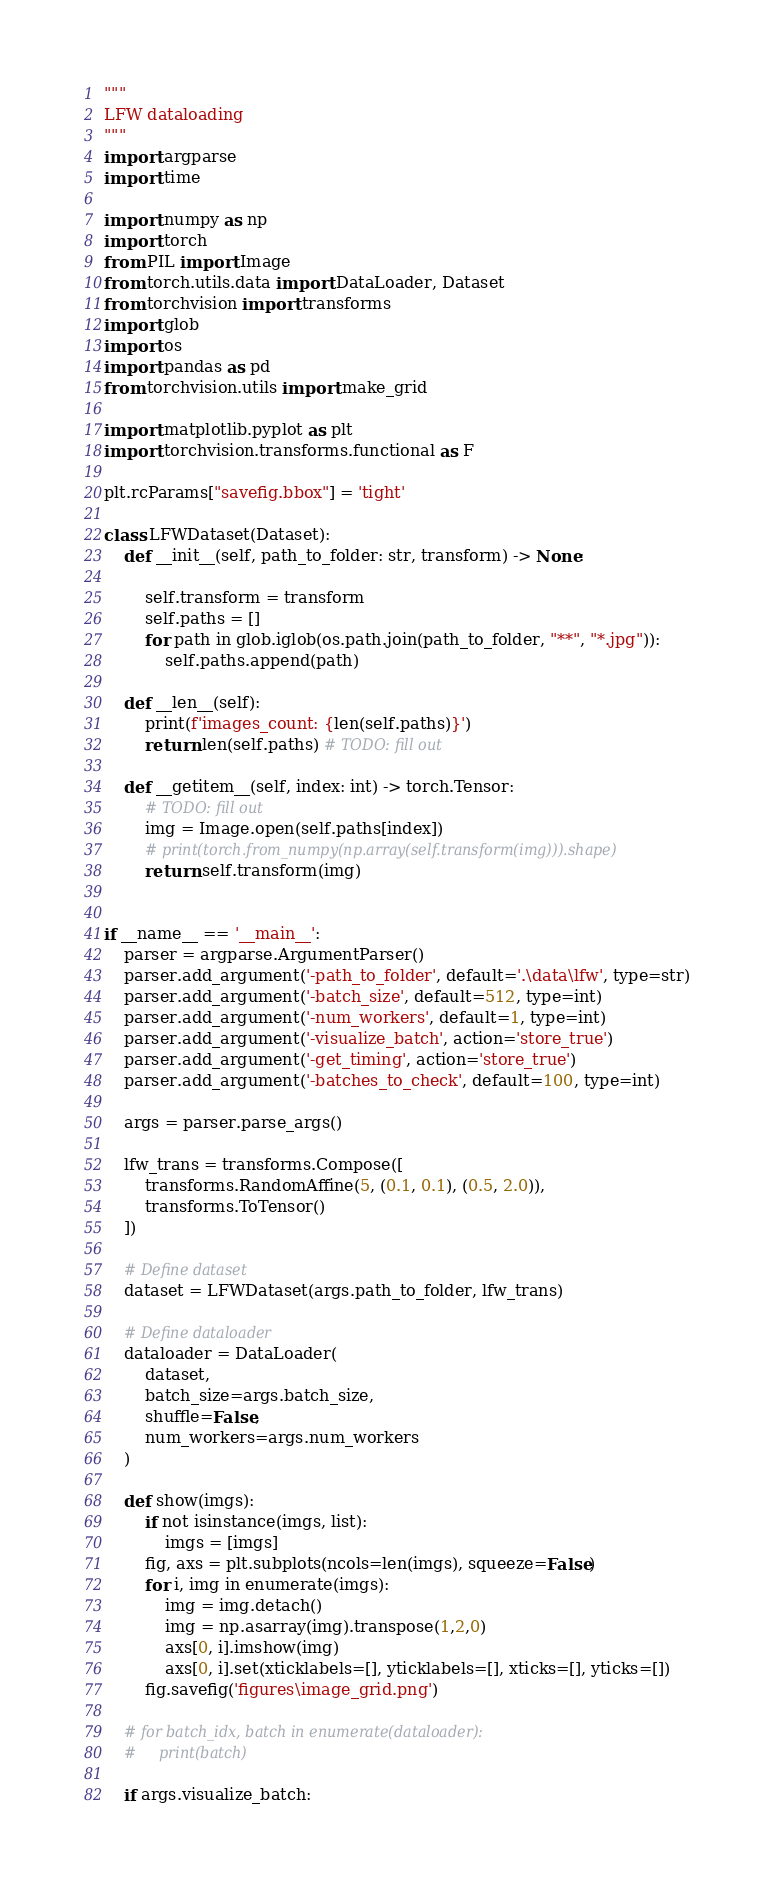<code> <loc_0><loc_0><loc_500><loc_500><_Python_>"""
LFW dataloading
"""
import argparse
import time

import numpy as np
import torch
from PIL import Image
from torch.utils.data import DataLoader, Dataset
from torchvision import transforms
import glob
import os
import pandas as pd
from torchvision.utils import make_grid

import matplotlib.pyplot as plt
import torchvision.transforms.functional as F

plt.rcParams["savefig.bbox"] = 'tight'

class LFWDataset(Dataset):
    def __init__(self, path_to_folder: str, transform) -> None:

        self.transform = transform
        self.paths = []
        for path in glob.iglob(os.path.join(path_to_folder, "**", "*.jpg")):
            self.paths.append(path)
            
    def __len__(self):
        print(f'images_count: {len(self.paths)}')
        return len(self.paths) # TODO: fill out
    
    def __getitem__(self, index: int) -> torch.Tensor:
        # TODO: fill out
        img = Image.open(self.paths[index])
        # print(torch.from_numpy(np.array(self.transform(img))).shape)
        return self.transform(img)

        
if __name__ == '__main__':
    parser = argparse.ArgumentParser()
    parser.add_argument('-path_to_folder', default='.\data\lfw', type=str)
    parser.add_argument('-batch_size', default=512, type=int)
    parser.add_argument('-num_workers', default=1, type=int)
    parser.add_argument('-visualize_batch', action='store_true')
    parser.add_argument('-get_timing', action='store_true')
    parser.add_argument('-batches_to_check', default=100, type=int)
    
    args = parser.parse_args()
    
    lfw_trans = transforms.Compose([
        transforms.RandomAffine(5, (0.1, 0.1), (0.5, 2.0)),
        transforms.ToTensor()
    ])
    
    # Define dataset
    dataset = LFWDataset(args.path_to_folder, lfw_trans)
    
    # Define dataloader
    dataloader = DataLoader(
        dataset, 
        batch_size=args.batch_size, 
        shuffle=False,
        num_workers=args.num_workers
    )
    
    def show(imgs):
        if not isinstance(imgs, list):
            imgs = [imgs]
        fig, axs = plt.subplots(ncols=len(imgs), squeeze=False)
        for i, img in enumerate(imgs):
            img = img.detach()
            img = np.asarray(img).transpose(1,2,0)
            axs[0, i].imshow(img)
            axs[0, i].set(xticklabels=[], yticklabels=[], xticks=[], yticks=[])
        fig.savefig('figures\image_grid.png')

    # for batch_idx, batch in enumerate(dataloader):
    #     print(batch)

    if args.visualize_batch:</code> 